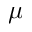<formula> <loc_0><loc_0><loc_500><loc_500>\mu</formula> 